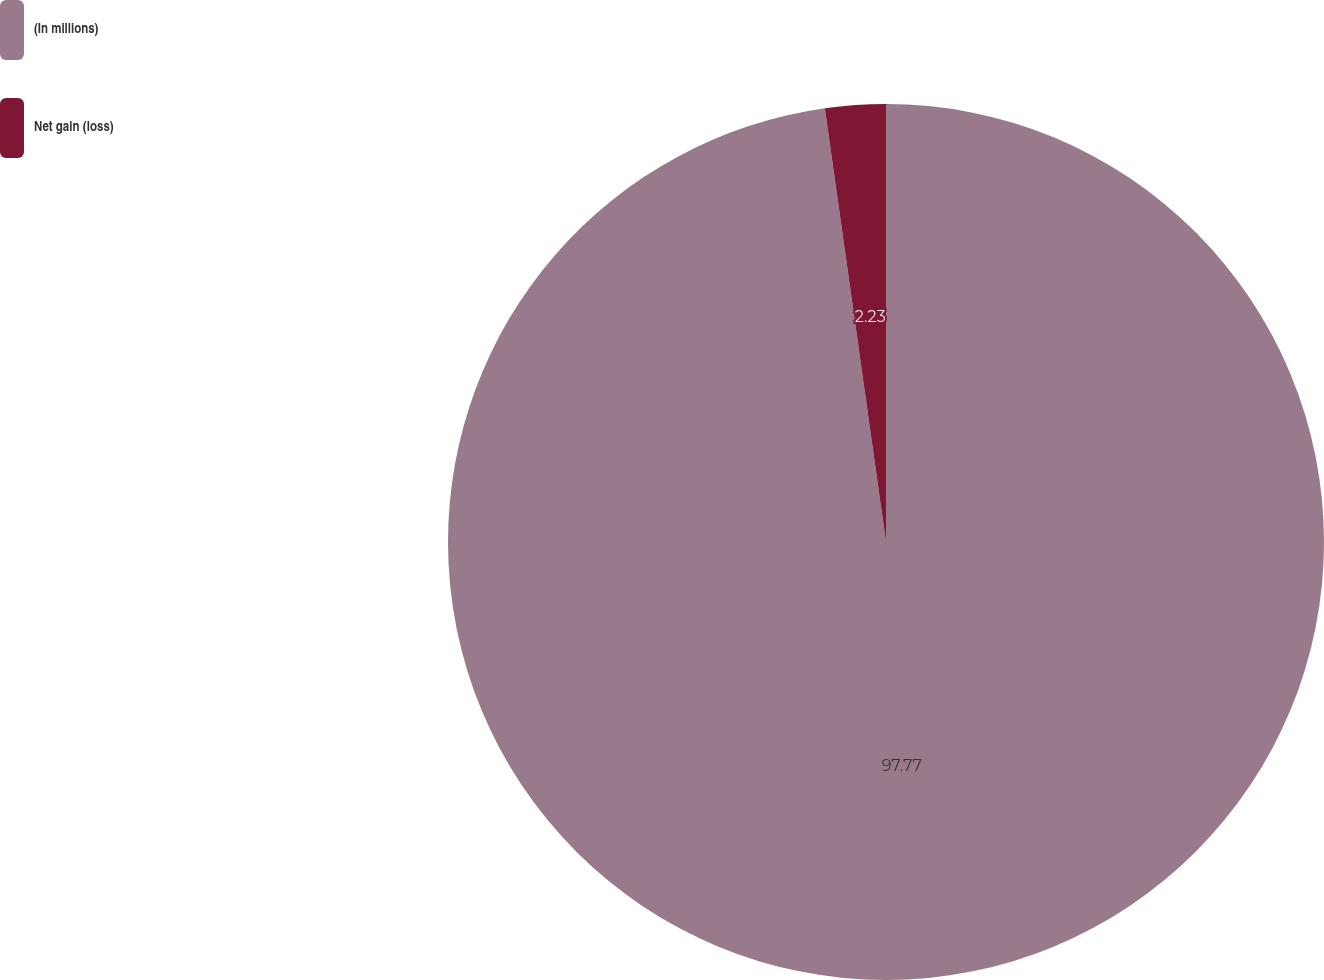Convert chart to OTSL. <chart><loc_0><loc_0><loc_500><loc_500><pie_chart><fcel>(In millions)<fcel>Net gain (loss)<nl><fcel>97.77%<fcel>2.23%<nl></chart> 